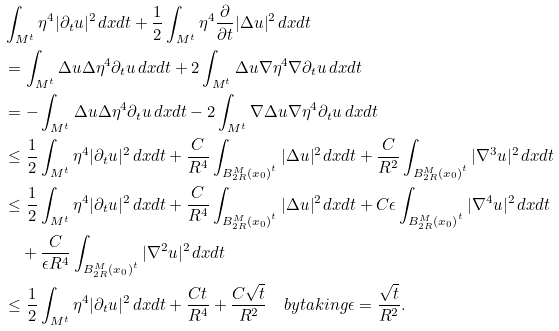<formula> <loc_0><loc_0><loc_500><loc_500>& \int _ { M ^ { t } } \eta ^ { 4 } | \partial _ { t } u | ^ { 2 } \, d x d t + \frac { 1 } { 2 } \int _ { M ^ { t } } \eta ^ { 4 } \frac { \partial } { \partial t } | \Delta u | ^ { 2 } \, d x d t \\ & = \int _ { M ^ { t } } \Delta u \Delta \eta ^ { 4 } \partial _ { t } u \, d x d t + 2 \int _ { M ^ { t } } \Delta u \nabla \eta ^ { 4 } \nabla \partial _ { t } u \, d x d t \\ & = - \int _ { M ^ { t } } \Delta u \Delta \eta ^ { 4 } \partial _ { t } u \, d x d t - 2 \int _ { M ^ { t } } \nabla \Delta u \nabla \eta ^ { 4 } \partial _ { t } u \, d x d t \\ & \leq \frac { 1 } { 2 } \int _ { M ^ { t } } \eta ^ { 4 } | \partial _ { t } u | ^ { 2 } \, d x d t + \frac { C } { R ^ { 4 } } \int _ { { B ^ { M } _ { 2 R } ( x _ { 0 } ) } ^ { t } } | \Delta u | ^ { 2 } \, d x d t + \frac { C } { R ^ { 2 } } \int _ { { B ^ { M } _ { 2 R } ( x _ { 0 } ) } ^ { t } } | \nabla ^ { 3 } u | ^ { 2 } \, d x d t \\ & \leq \frac { 1 } { 2 } \int _ { M ^ { t } } \eta ^ { 4 } | \partial _ { t } u | ^ { 2 } \, d x d t + \frac { C } { R ^ { 4 } } \int _ { { B ^ { M } _ { 2 R } ( x _ { 0 } ) } ^ { t } } | \Delta u | ^ { 2 } \, d x d t + C \epsilon \int _ { { B ^ { M } _ { 2 R } ( x _ { 0 } ) } ^ { t } } | \nabla ^ { 4 } u | ^ { 2 } \, d x d t \\ & \quad + \frac { C } { \epsilon R ^ { 4 } } \int _ { { B ^ { M } _ { 2 R } ( x _ { 0 } ) } ^ { t } } | \nabla ^ { 2 } u | ^ { 2 } \, d x d t \\ & \leq \frac { 1 } { 2 } \int _ { M ^ { t } } \eta ^ { 4 } | \partial _ { t } u | ^ { 2 } \, d x d t + \frac { C t } { R ^ { 4 } } + \frac { C \sqrt { t } } { R ^ { 2 } } \quad b y t a k i n g \epsilon = \frac { \sqrt { t } } { R ^ { 2 } } .</formula> 